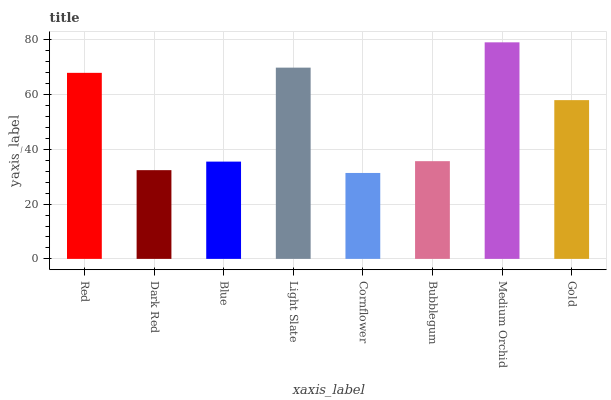Is Cornflower the minimum?
Answer yes or no. Yes. Is Medium Orchid the maximum?
Answer yes or no. Yes. Is Dark Red the minimum?
Answer yes or no. No. Is Dark Red the maximum?
Answer yes or no. No. Is Red greater than Dark Red?
Answer yes or no. Yes. Is Dark Red less than Red?
Answer yes or no. Yes. Is Dark Red greater than Red?
Answer yes or no. No. Is Red less than Dark Red?
Answer yes or no. No. Is Gold the high median?
Answer yes or no. Yes. Is Bubblegum the low median?
Answer yes or no. Yes. Is Red the high median?
Answer yes or no. No. Is Gold the low median?
Answer yes or no. No. 